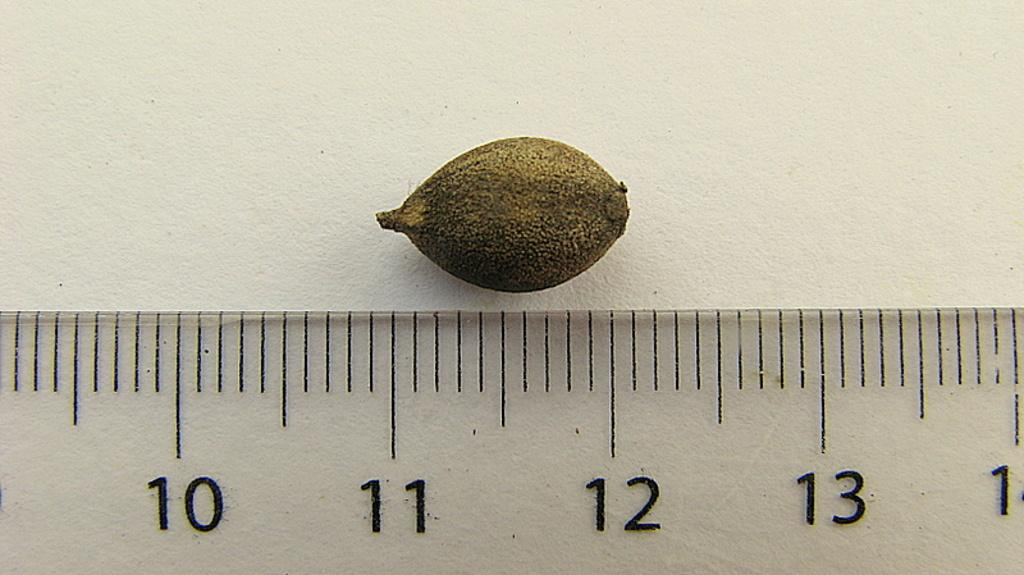Provide a one-sentence caption for the provided image. Ruler being used to measure a seed which is above the 11 and 12 inch markers. 